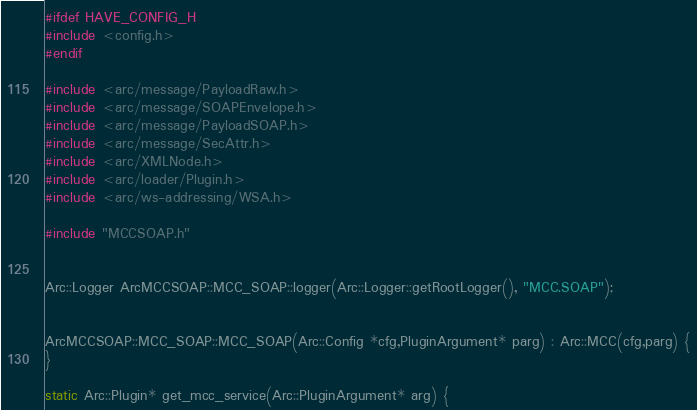Convert code to text. <code><loc_0><loc_0><loc_500><loc_500><_C++_>#ifdef HAVE_CONFIG_H
#include <config.h>
#endif

#include <arc/message/PayloadRaw.h>
#include <arc/message/SOAPEnvelope.h>
#include <arc/message/PayloadSOAP.h>
#include <arc/message/SecAttr.h>
#include <arc/XMLNode.h>
#include <arc/loader/Plugin.h>
#include <arc/ws-addressing/WSA.h>

#include "MCCSOAP.h"


Arc::Logger ArcMCCSOAP::MCC_SOAP::logger(Arc::Logger::getRootLogger(), "MCC.SOAP");


ArcMCCSOAP::MCC_SOAP::MCC_SOAP(Arc::Config *cfg,PluginArgument* parg) : Arc::MCC(cfg,parg) {
}

static Arc::Plugin* get_mcc_service(Arc::PluginArgument* arg) {</code> 